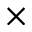Convert formula to latex. <formula><loc_0><loc_0><loc_500><loc_500>\times</formula> 